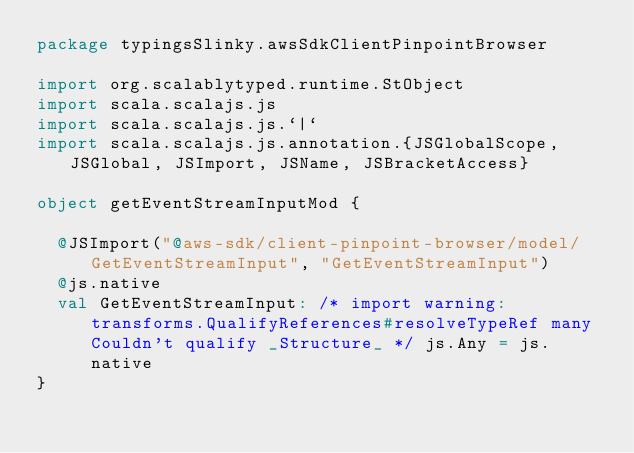<code> <loc_0><loc_0><loc_500><loc_500><_Scala_>package typingsSlinky.awsSdkClientPinpointBrowser

import org.scalablytyped.runtime.StObject
import scala.scalajs.js
import scala.scalajs.js.`|`
import scala.scalajs.js.annotation.{JSGlobalScope, JSGlobal, JSImport, JSName, JSBracketAccess}

object getEventStreamInputMod {
  
  @JSImport("@aws-sdk/client-pinpoint-browser/model/GetEventStreamInput", "GetEventStreamInput")
  @js.native
  val GetEventStreamInput: /* import warning: transforms.QualifyReferences#resolveTypeRef many Couldn't qualify _Structure_ */ js.Any = js.native
}
</code> 